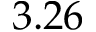<formula> <loc_0><loc_0><loc_500><loc_500>3 . 2 6</formula> 